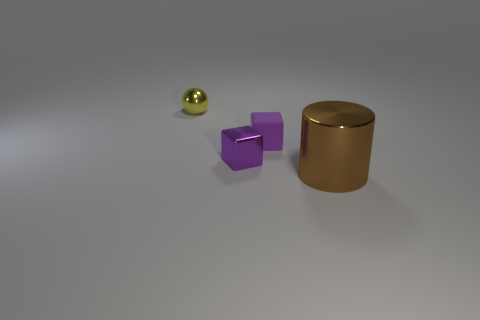What is the shape of the matte object that is the same color as the shiny block?
Keep it short and to the point. Cube. What color is the small metallic thing that is in front of the small purple rubber block?
Offer a terse response. Purple. What number of other things are the same size as the shiny cylinder?
Your answer should be very brief. 0. Is there anything else that has the same shape as the small yellow metallic object?
Your answer should be very brief. No. Are there an equal number of brown cylinders in front of the metallic block and brown things?
Keep it short and to the point. Yes. How many small purple things are made of the same material as the yellow object?
Keep it short and to the point. 1. What color is the ball that is the same material as the brown cylinder?
Keep it short and to the point. Yellow. Is the shape of the tiny purple shiny object the same as the tiny purple matte thing?
Offer a very short reply. Yes. Is there a metallic block that is right of the thing that is on the left side of the small metallic object that is on the right side of the yellow metallic sphere?
Offer a terse response. Yes. How many small metallic things have the same color as the small matte thing?
Your response must be concise. 1. 